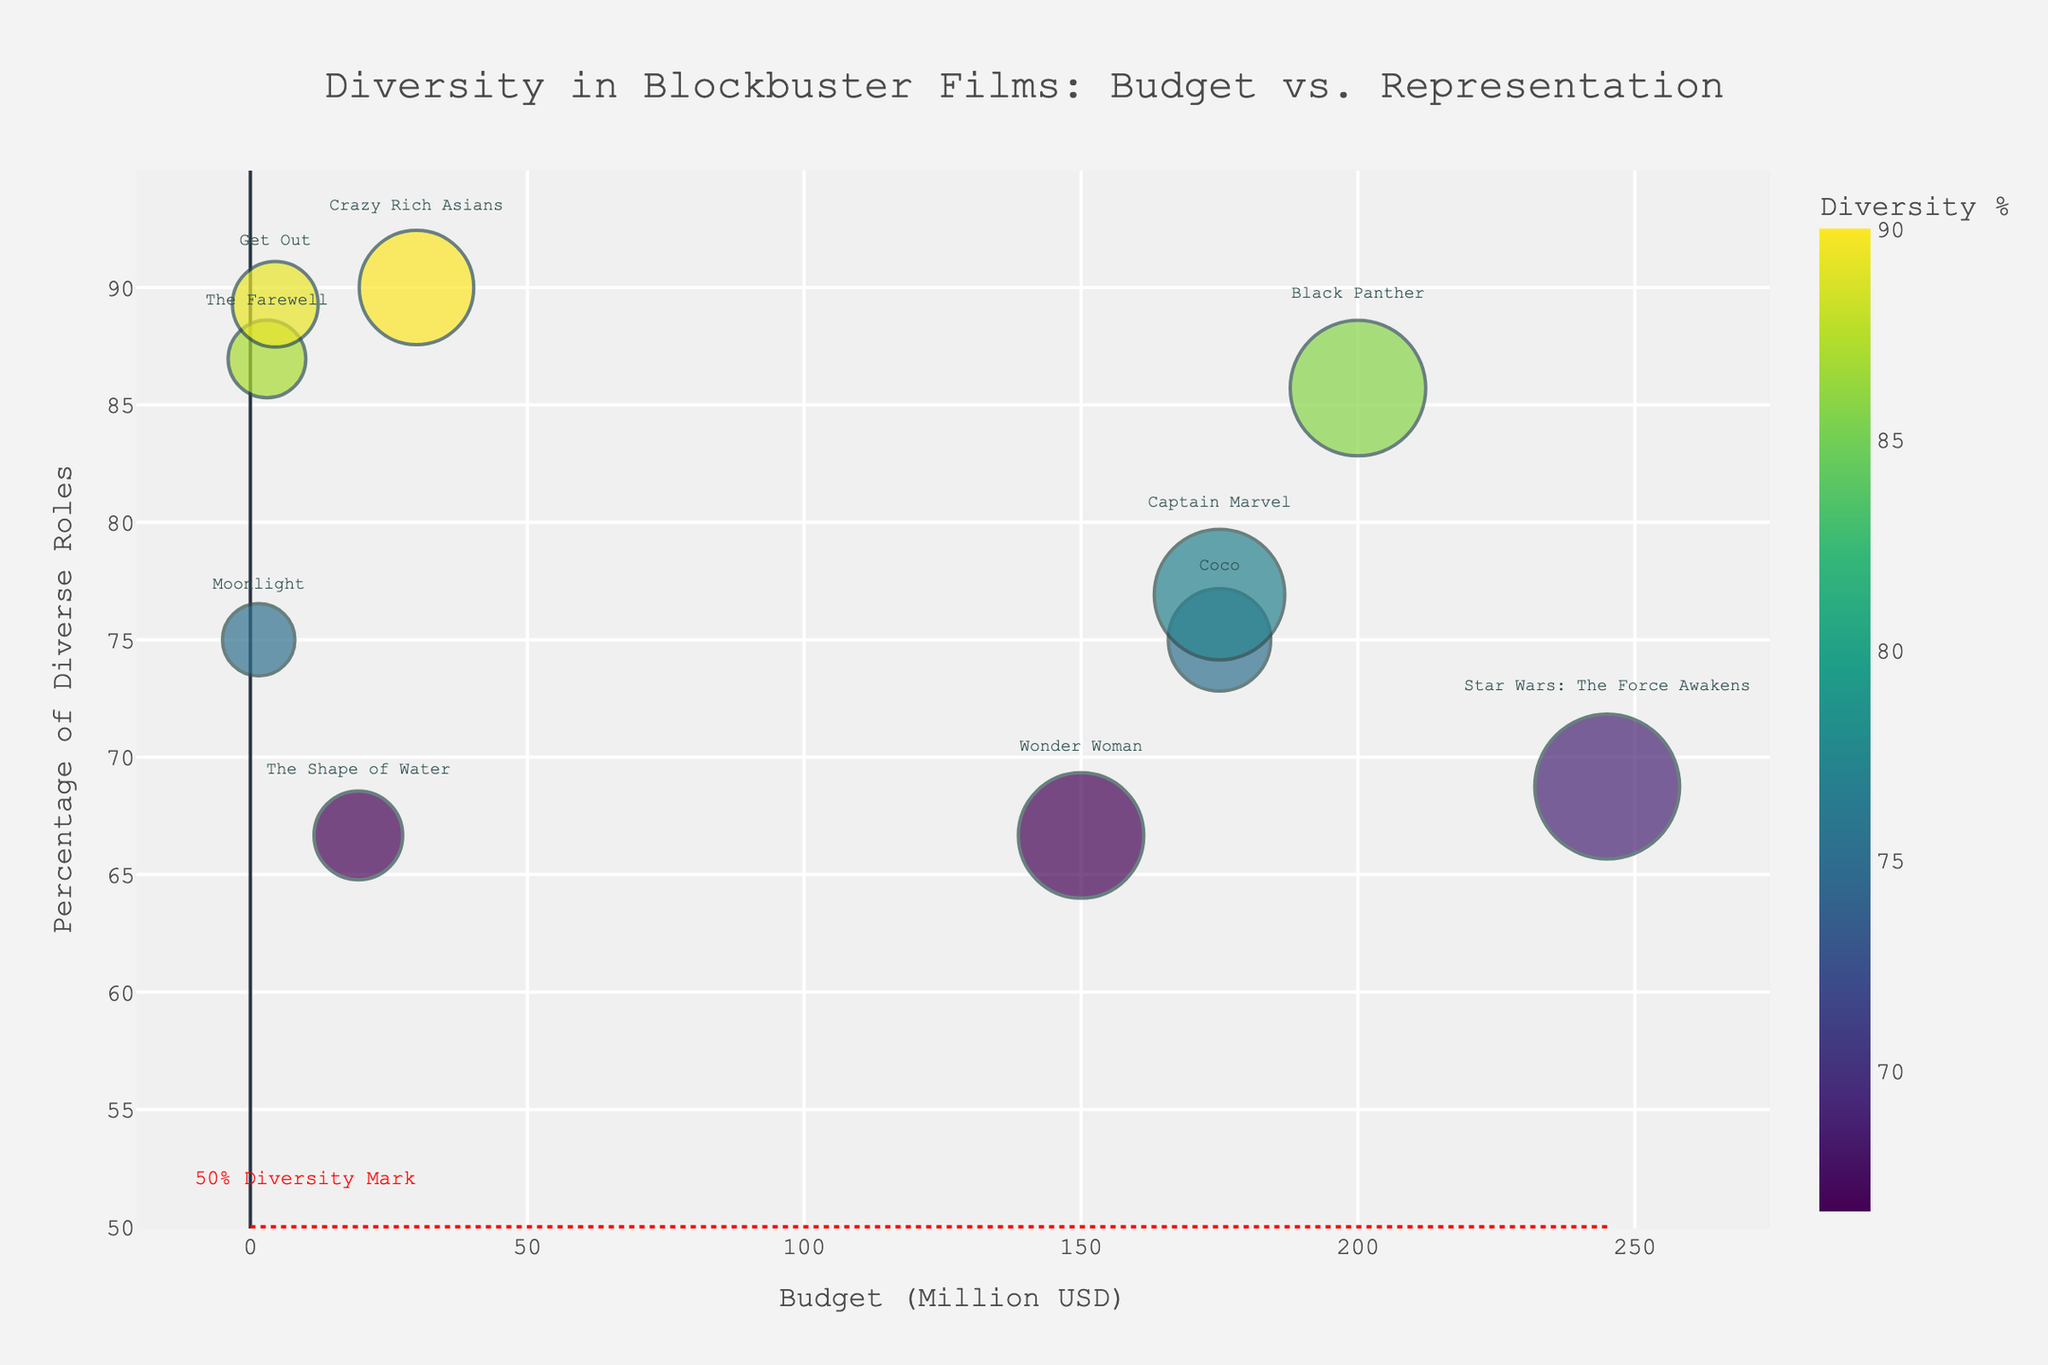What is the title of the Bubble Chart? The title is usually prominently displayed at the top of the chart. In this figure, the title can be read directly from the top middle of the chart.
Answer: Diversity in Blockbuster Films: Budget vs. Representation What is the horizontal axis label? The horizontal axis, or x-axis, label is typically found at the bottom of the chart and indicates the variable plotted on this axis.
Answer: Budget (Million USD) What does the color of a bubble indicate? The color indicates the percentage of diverse roles, as shown by the color bar legend titled "Diversity %" next to the chart.
Answer: Percentage of diverse roles Which film has the highest budget? The film with the highest budget can be found by identifying the bubble furthest to the right on the x-axis.
Answer: Star Wars: The Force Awakens How many films have a more than 50% diversity percentage? This requires counting the bubbles positioned above the 50% diversity mark, identified by a dotted red line across the chart.
Answer: 7 films What is the budget for the film "Get Out"? Locate the bubble labeled "Get Out" and check its position on the x-axis to find its budget.
Answer: 4.5 million USD Which film has the largest bubble size? The largest bubble size indicates the film with the highest total number of roles. Visual inspection of the chart shows which bubble is the largest.
Answer: Black Panther Compare the diversity percentage of "Coco" with "The Farewell". Find the bubbles labeled "Coco" and "The Farewell" and compare their positions on the y-axis to determine which has a higher diversity percentage.
Answer: The Farewell has a higher percentage What is the approximate diversity percentage for "Crazy Rich Asians"? Look for the "Crazy Rich Asians" bubble and check its position on the y-axis to estimate the percentage.
Answer: Approximately 90% Compare the budget and total roles of "Captain Marvel" and "Wonder Woman". Identify the bubbles for both films, read their x-axis positions for budgets and compare bubble sizes for total roles.
Answer: "Captain Marvel" has a higher budget and more total roles 